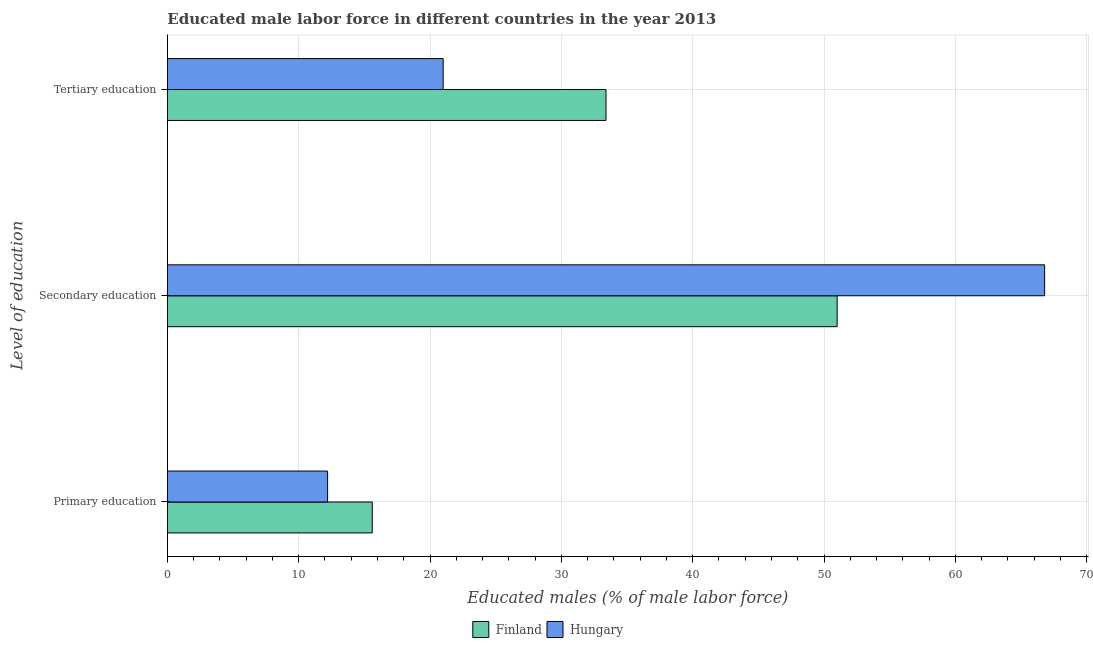How many different coloured bars are there?
Your answer should be compact. 2. Are the number of bars per tick equal to the number of legend labels?
Provide a short and direct response. Yes. What is the label of the 2nd group of bars from the top?
Ensure brevity in your answer.  Secondary education. What is the percentage of male labor force who received primary education in Hungary?
Your response must be concise. 12.2. Across all countries, what is the maximum percentage of male labor force who received primary education?
Keep it short and to the point. 15.6. Across all countries, what is the minimum percentage of male labor force who received secondary education?
Your answer should be compact. 51. In which country was the percentage of male labor force who received secondary education maximum?
Keep it short and to the point. Hungary. In which country was the percentage of male labor force who received secondary education minimum?
Your answer should be compact. Finland. What is the total percentage of male labor force who received primary education in the graph?
Offer a very short reply. 27.8. What is the difference between the percentage of male labor force who received primary education in Finland and that in Hungary?
Ensure brevity in your answer.  3.4. What is the difference between the percentage of male labor force who received secondary education in Hungary and the percentage of male labor force who received primary education in Finland?
Offer a very short reply. 51.2. What is the average percentage of male labor force who received secondary education per country?
Ensure brevity in your answer.  58.9. What is the difference between the percentage of male labor force who received primary education and percentage of male labor force who received secondary education in Finland?
Ensure brevity in your answer.  -35.4. In how many countries, is the percentage of male labor force who received tertiary education greater than 48 %?
Provide a succinct answer. 0. What is the ratio of the percentage of male labor force who received primary education in Hungary to that in Finland?
Your answer should be very brief. 0.78. Is the percentage of male labor force who received tertiary education in Finland less than that in Hungary?
Offer a terse response. No. Is the difference between the percentage of male labor force who received secondary education in Hungary and Finland greater than the difference between the percentage of male labor force who received tertiary education in Hungary and Finland?
Keep it short and to the point. Yes. What is the difference between the highest and the second highest percentage of male labor force who received secondary education?
Give a very brief answer. 15.8. What is the difference between the highest and the lowest percentage of male labor force who received tertiary education?
Keep it short and to the point. 12.4. In how many countries, is the percentage of male labor force who received secondary education greater than the average percentage of male labor force who received secondary education taken over all countries?
Ensure brevity in your answer.  1. Is the sum of the percentage of male labor force who received primary education in Finland and Hungary greater than the maximum percentage of male labor force who received secondary education across all countries?
Give a very brief answer. No. What does the 2nd bar from the top in Primary education represents?
Offer a very short reply. Finland. What does the 2nd bar from the bottom in Tertiary education represents?
Your answer should be compact. Hungary. Is it the case that in every country, the sum of the percentage of male labor force who received primary education and percentage of male labor force who received secondary education is greater than the percentage of male labor force who received tertiary education?
Your response must be concise. Yes. How many bars are there?
Keep it short and to the point. 6. Are all the bars in the graph horizontal?
Offer a terse response. Yes. How many countries are there in the graph?
Provide a succinct answer. 2. What is the difference between two consecutive major ticks on the X-axis?
Your answer should be compact. 10. Does the graph contain grids?
Ensure brevity in your answer.  Yes. Where does the legend appear in the graph?
Your response must be concise. Bottom center. What is the title of the graph?
Keep it short and to the point. Educated male labor force in different countries in the year 2013. Does "Greenland" appear as one of the legend labels in the graph?
Your answer should be very brief. No. What is the label or title of the X-axis?
Provide a succinct answer. Educated males (% of male labor force). What is the label or title of the Y-axis?
Give a very brief answer. Level of education. What is the Educated males (% of male labor force) in Finland in Primary education?
Provide a short and direct response. 15.6. What is the Educated males (% of male labor force) in Hungary in Primary education?
Offer a terse response. 12.2. What is the Educated males (% of male labor force) of Hungary in Secondary education?
Keep it short and to the point. 66.8. What is the Educated males (% of male labor force) of Finland in Tertiary education?
Make the answer very short. 33.4. Across all Level of education, what is the maximum Educated males (% of male labor force) in Finland?
Ensure brevity in your answer.  51. Across all Level of education, what is the maximum Educated males (% of male labor force) in Hungary?
Provide a short and direct response. 66.8. Across all Level of education, what is the minimum Educated males (% of male labor force) in Finland?
Offer a terse response. 15.6. Across all Level of education, what is the minimum Educated males (% of male labor force) in Hungary?
Keep it short and to the point. 12.2. What is the total Educated males (% of male labor force) of Finland in the graph?
Give a very brief answer. 100. What is the total Educated males (% of male labor force) in Hungary in the graph?
Keep it short and to the point. 100. What is the difference between the Educated males (% of male labor force) in Finland in Primary education and that in Secondary education?
Ensure brevity in your answer.  -35.4. What is the difference between the Educated males (% of male labor force) of Hungary in Primary education and that in Secondary education?
Ensure brevity in your answer.  -54.6. What is the difference between the Educated males (% of male labor force) of Finland in Primary education and that in Tertiary education?
Keep it short and to the point. -17.8. What is the difference between the Educated males (% of male labor force) in Hungary in Secondary education and that in Tertiary education?
Your response must be concise. 45.8. What is the difference between the Educated males (% of male labor force) of Finland in Primary education and the Educated males (% of male labor force) of Hungary in Secondary education?
Provide a short and direct response. -51.2. What is the difference between the Educated males (% of male labor force) in Finland in Primary education and the Educated males (% of male labor force) in Hungary in Tertiary education?
Give a very brief answer. -5.4. What is the average Educated males (% of male labor force) of Finland per Level of education?
Ensure brevity in your answer.  33.33. What is the average Educated males (% of male labor force) of Hungary per Level of education?
Ensure brevity in your answer.  33.33. What is the difference between the Educated males (% of male labor force) in Finland and Educated males (% of male labor force) in Hungary in Secondary education?
Provide a short and direct response. -15.8. What is the ratio of the Educated males (% of male labor force) in Finland in Primary education to that in Secondary education?
Give a very brief answer. 0.31. What is the ratio of the Educated males (% of male labor force) in Hungary in Primary education to that in Secondary education?
Your response must be concise. 0.18. What is the ratio of the Educated males (% of male labor force) in Finland in Primary education to that in Tertiary education?
Offer a terse response. 0.47. What is the ratio of the Educated males (% of male labor force) of Hungary in Primary education to that in Tertiary education?
Provide a short and direct response. 0.58. What is the ratio of the Educated males (% of male labor force) in Finland in Secondary education to that in Tertiary education?
Offer a terse response. 1.53. What is the ratio of the Educated males (% of male labor force) in Hungary in Secondary education to that in Tertiary education?
Your answer should be very brief. 3.18. What is the difference between the highest and the second highest Educated males (% of male labor force) in Hungary?
Your answer should be very brief. 45.8. What is the difference between the highest and the lowest Educated males (% of male labor force) in Finland?
Provide a short and direct response. 35.4. What is the difference between the highest and the lowest Educated males (% of male labor force) of Hungary?
Provide a succinct answer. 54.6. 